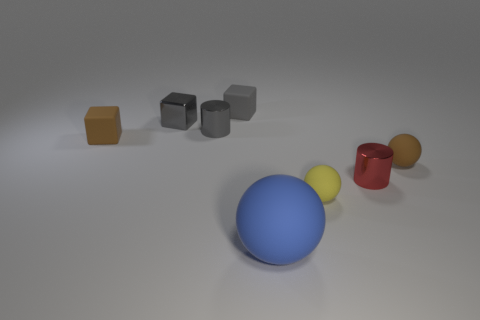Add 1 tiny brown matte cubes. How many objects exist? 9 Subtract all cubes. How many objects are left? 5 Add 5 matte cubes. How many matte cubes exist? 7 Subtract 0 red balls. How many objects are left? 8 Subtract all large red metallic things. Subtract all gray metallic things. How many objects are left? 6 Add 8 blue matte things. How many blue matte things are left? 9 